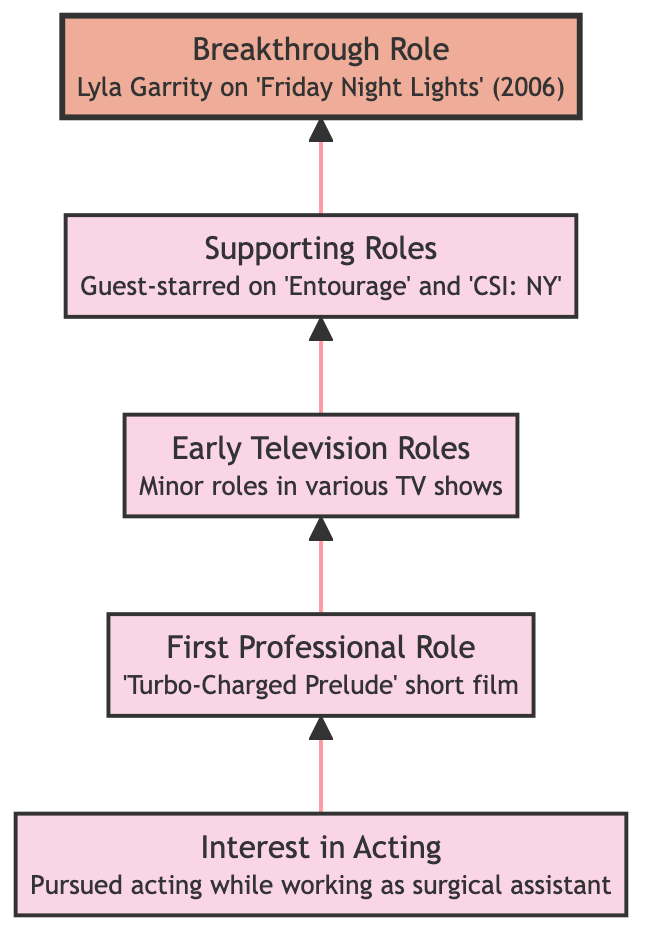What is the first step in Minka Kelly's career progression? The diagram shows that the first step is "Interest in Acting," indicating her initial pursuit of acting.
Answer: Interest in Acting Which film marked Minka Kelly's first professional role? According to the diagram, Minka Kelly's first professional role was in the short film "Turbo-Charged Prelude."
Answer: Turbo-Charged Prelude How many early television roles did Minka Kelly have? The diagram indicates that she had minor roles in several TV shows; while it does not give a specific number, it lists multiple shows as examples. Thus, counting them gives a total of four shows: "Cracking Up," "American Dreams," "Drake & Josh," and "What I Like About You."
Answer: 4 What did Minka Kelly achieve in 2006? The breakthrough role she secured in 2006 is highlighted in the diagram, indicating this was a significant event in her career. The role was as Lyla Garrity on "Friday Night Lights."
Answer: Lyla Garrity on 'Friday Night Lights' What kind of roles did Minka Kelly perform after her first professional role? Following her first role, the diagram indicates that she took on early television roles, as well as supporting roles, suggesting a progression from minor to more significant parts.
Answer: Early Television Roles and Supporting Roles How does Minka Kelly's breakthrough role relate to her prior experience? The diagram illustrates a clear progression from earlier minor roles to guest-starring on series like "Entourage" and "CSI: NY," which provided her the experience necessary to secure her breakthrough role in "Friday Night Lights." This indicates that her earlier roles were foundational to her success.
Answer: Prior experience led to her breakthrough What is the significance of the highlighted box in the diagram? The highlighted box represents Minka Kelly's "Breakthrough Role" on "Friday Night Lights," indicating it is the culmination of her career progression before achieving stardom.
Answer: Significant breakthrough What do you see at the top of the diagram? The top of the diagram features Minka Kelly's breakthrough role, emphasizing its importance as the final step in her career progression shown in this chart.
Answer: Breakthrough Role Which two series did Minka Kelly guest-star in? The diagram states that she guest-starred on "Entourage" and "CSI: NY," providing specific series names showcasing her supporting roles.
Answer: Entourage and CSI: NY 